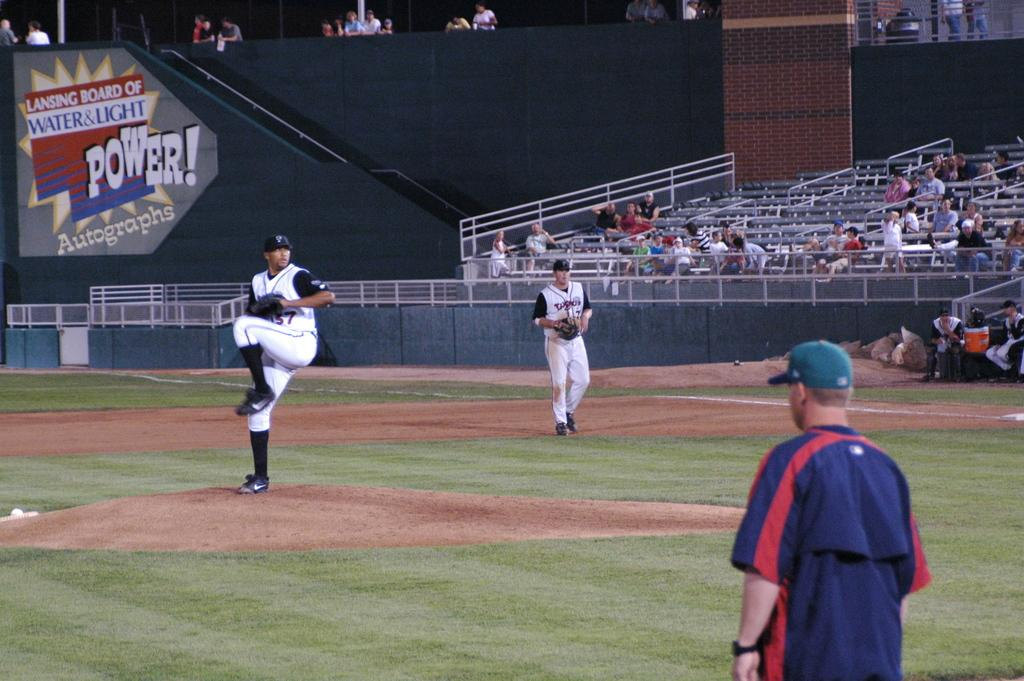<image>
Write a terse but informative summary of the picture. Power autographs for the players of the baseball game 